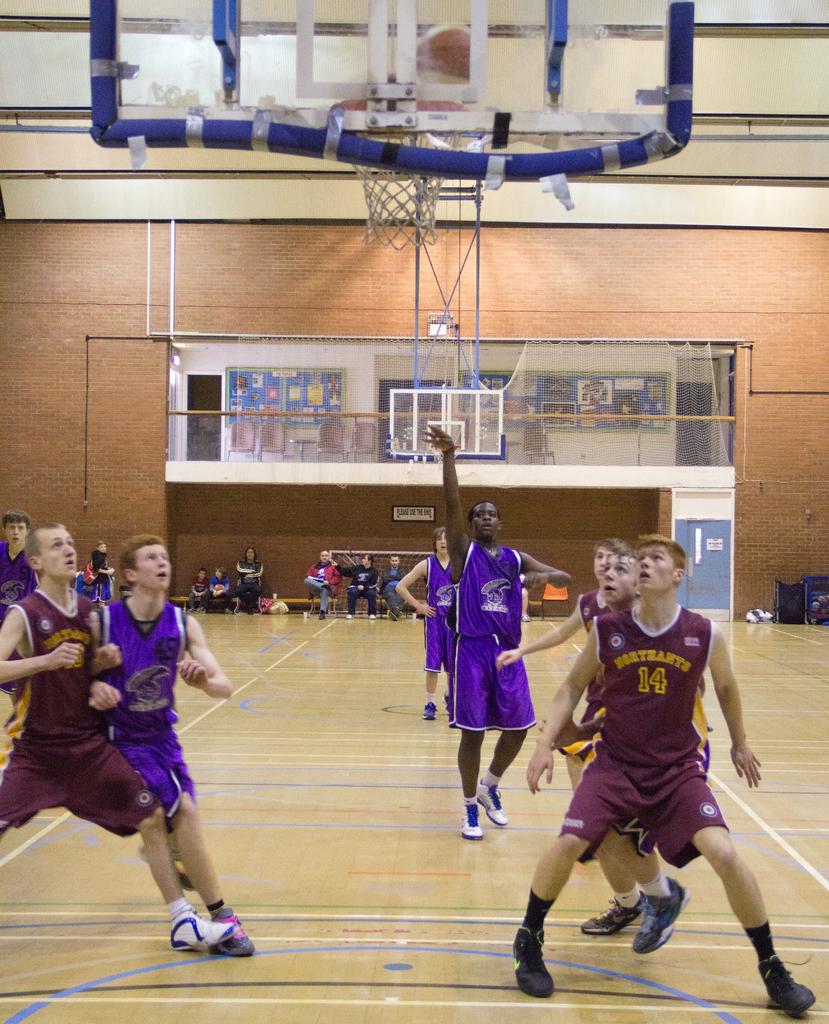What is the players number in the front right?
Offer a terse response. 14. What team is in the red jerseys?
Your answer should be compact. Unanswerable. 